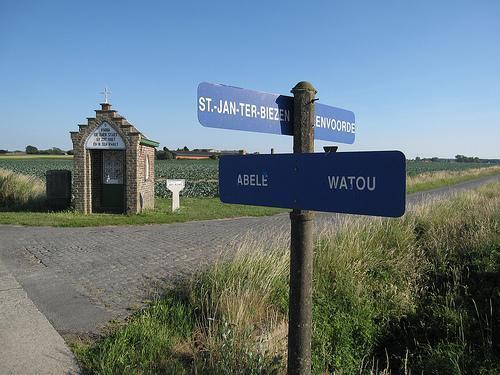How many signs are there?
Give a very brief answer. 2. 